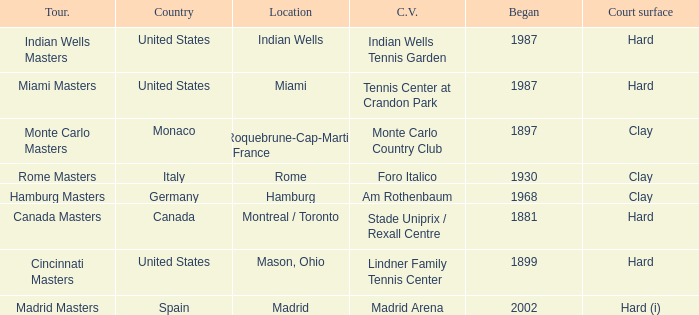What year was the tournament first held in Italy? 1930.0. 